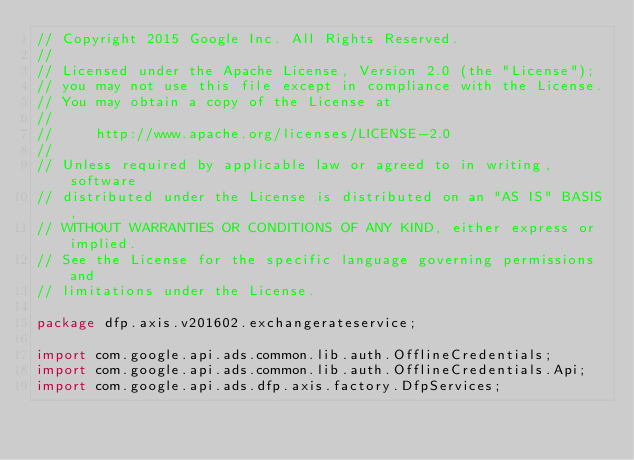Convert code to text. <code><loc_0><loc_0><loc_500><loc_500><_Java_>// Copyright 2015 Google Inc. All Rights Reserved.
//
// Licensed under the Apache License, Version 2.0 (the "License");
// you may not use this file except in compliance with the License.
// You may obtain a copy of the License at
//
//     http://www.apache.org/licenses/LICENSE-2.0
//
// Unless required by applicable law or agreed to in writing, software
// distributed under the License is distributed on an "AS IS" BASIS,
// WITHOUT WARRANTIES OR CONDITIONS OF ANY KIND, either express or implied.
// See the License for the specific language governing permissions and
// limitations under the License.

package dfp.axis.v201602.exchangerateservice;

import com.google.api.ads.common.lib.auth.OfflineCredentials;
import com.google.api.ads.common.lib.auth.OfflineCredentials.Api;
import com.google.api.ads.dfp.axis.factory.DfpServices;</code> 